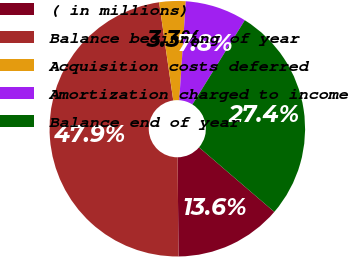<chart> <loc_0><loc_0><loc_500><loc_500><pie_chart><fcel>( in millions)<fcel>Balance beginning of year<fcel>Acquisition costs deferred<fcel>Amortization charged to income<fcel>Balance end of year<nl><fcel>13.57%<fcel>47.87%<fcel>3.34%<fcel>7.8%<fcel>27.42%<nl></chart> 